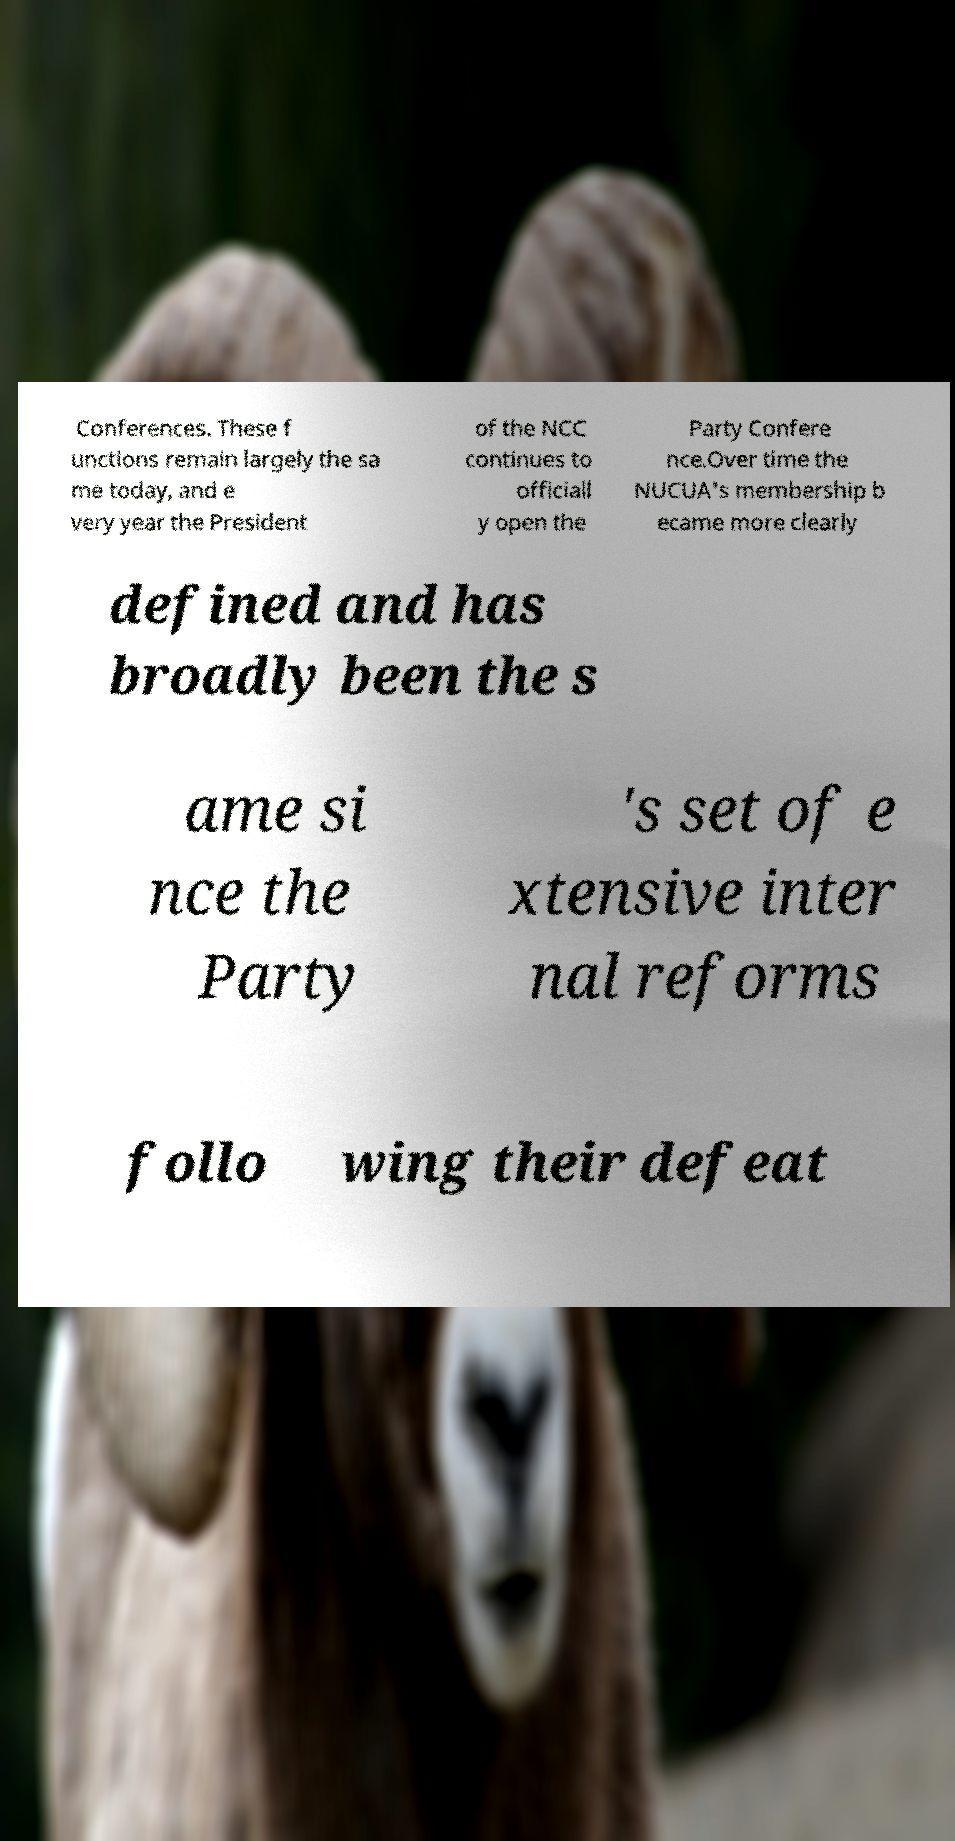Please read and relay the text visible in this image. What does it say? Conferences. These f unctions remain largely the sa me today, and e very year the President of the NCC continues to officiall y open the Party Confere nce.Over time the NUCUA's membership b ecame more clearly defined and has broadly been the s ame si nce the Party 's set of e xtensive inter nal reforms follo wing their defeat 